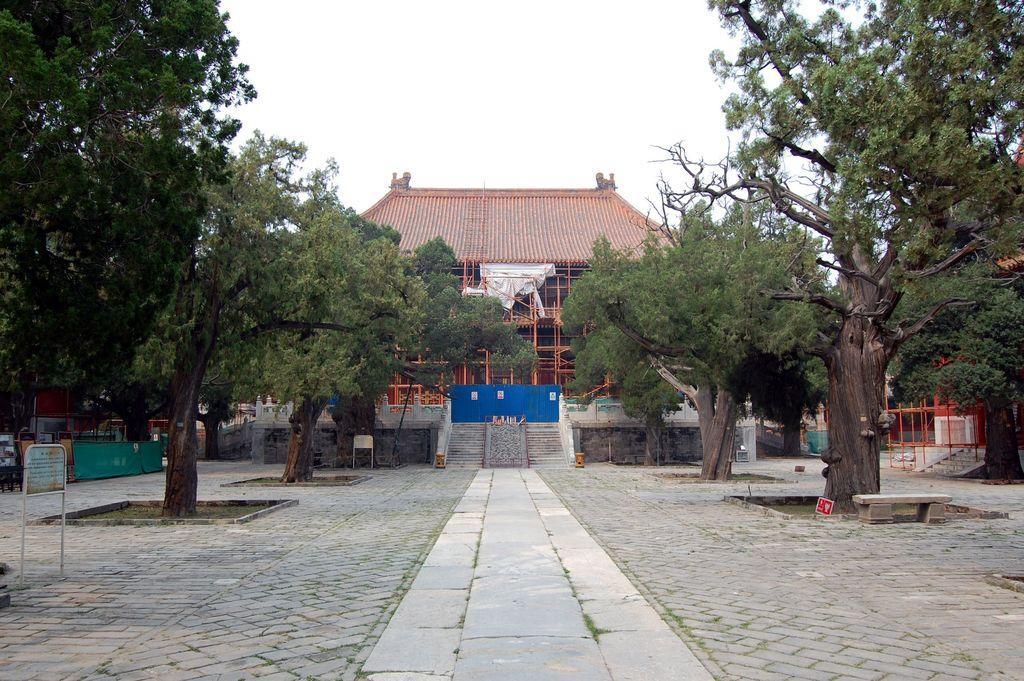Please provide a concise description of this image. In this picture we can see a path, steps, trees, boards, building, bench, walls and some objects and in the background we can see the sky. 